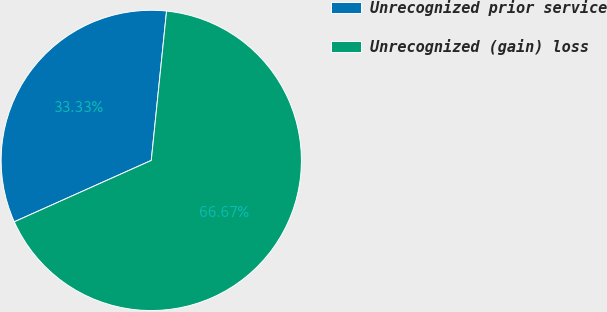<chart> <loc_0><loc_0><loc_500><loc_500><pie_chart><fcel>Unrecognized prior service<fcel>Unrecognized (gain) loss<nl><fcel>33.33%<fcel>66.67%<nl></chart> 